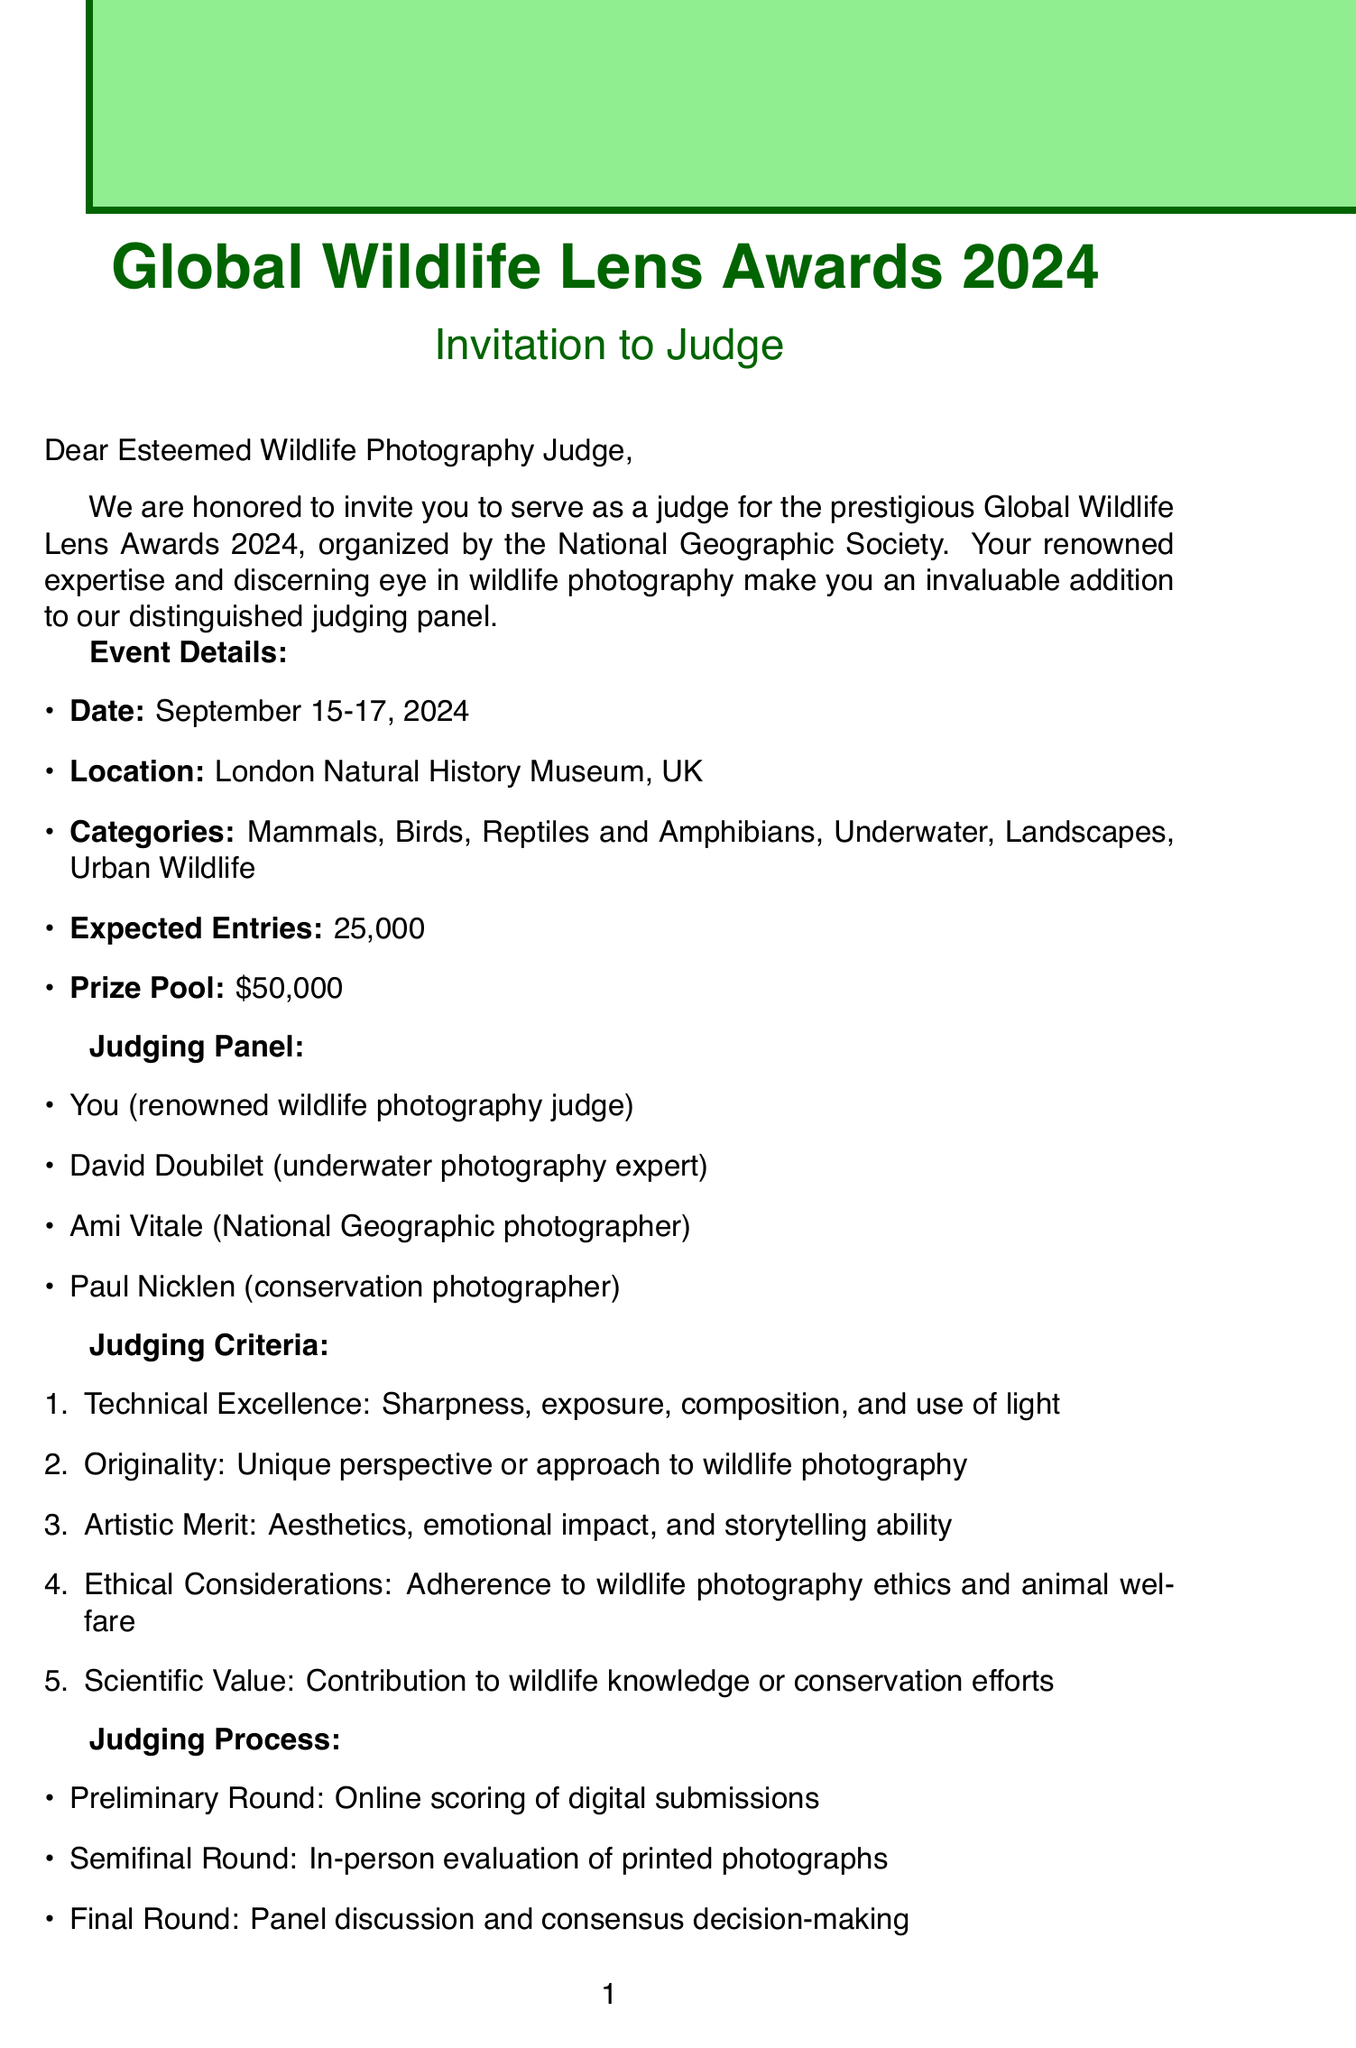What are the dates of the competition? The document states that the competition is scheduled for September 15-17, 2024.
Answer: September 15-17, 2024 Where will the event be held? The location of the event is indicated as the London Natural History Museum, UK.
Answer: London Natural History Museum, UK What is the expected number of entries? The document specifies that approximately 25,000 entries are expected for the competition.
Answer: 25,000 Who is a member of the judging panel? The document lists several judges, including you, as well as David Doubilet, Ami Vitale, and Paul Nicklen.
Answer: David Doubilet What is one of the judging criteria? The criteria include Technical Excellence, which refers to aspects like sharpness and composition.
Answer: Technical Excellence How much is the honorarium for judging services? The document mentions that the honorarium provided for the judging services is $5,000.
Answer: $5,000 What are the travel arrangements for judges? According to the document, first-class flights are provided for the judges attending the event.
Answer: First-class flights What percentage of entry fees is donated to wildlife protection projects? The document indicates that 10% of the entry fees will be donated to wildlife protection initiatives.
Answer: 10% What is the prize pool for the competition? The total prize pool stated in the document is $50,000.
Answer: $50,000 